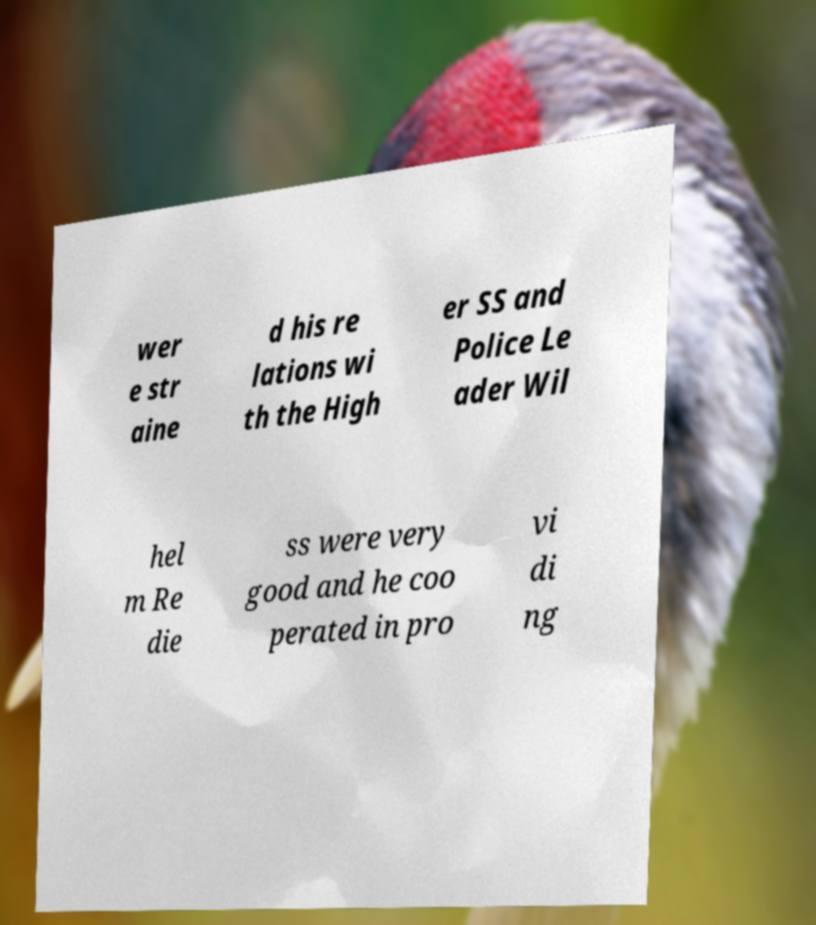Could you extract and type out the text from this image? wer e str aine d his re lations wi th the High er SS and Police Le ader Wil hel m Re die ss were very good and he coo perated in pro vi di ng 